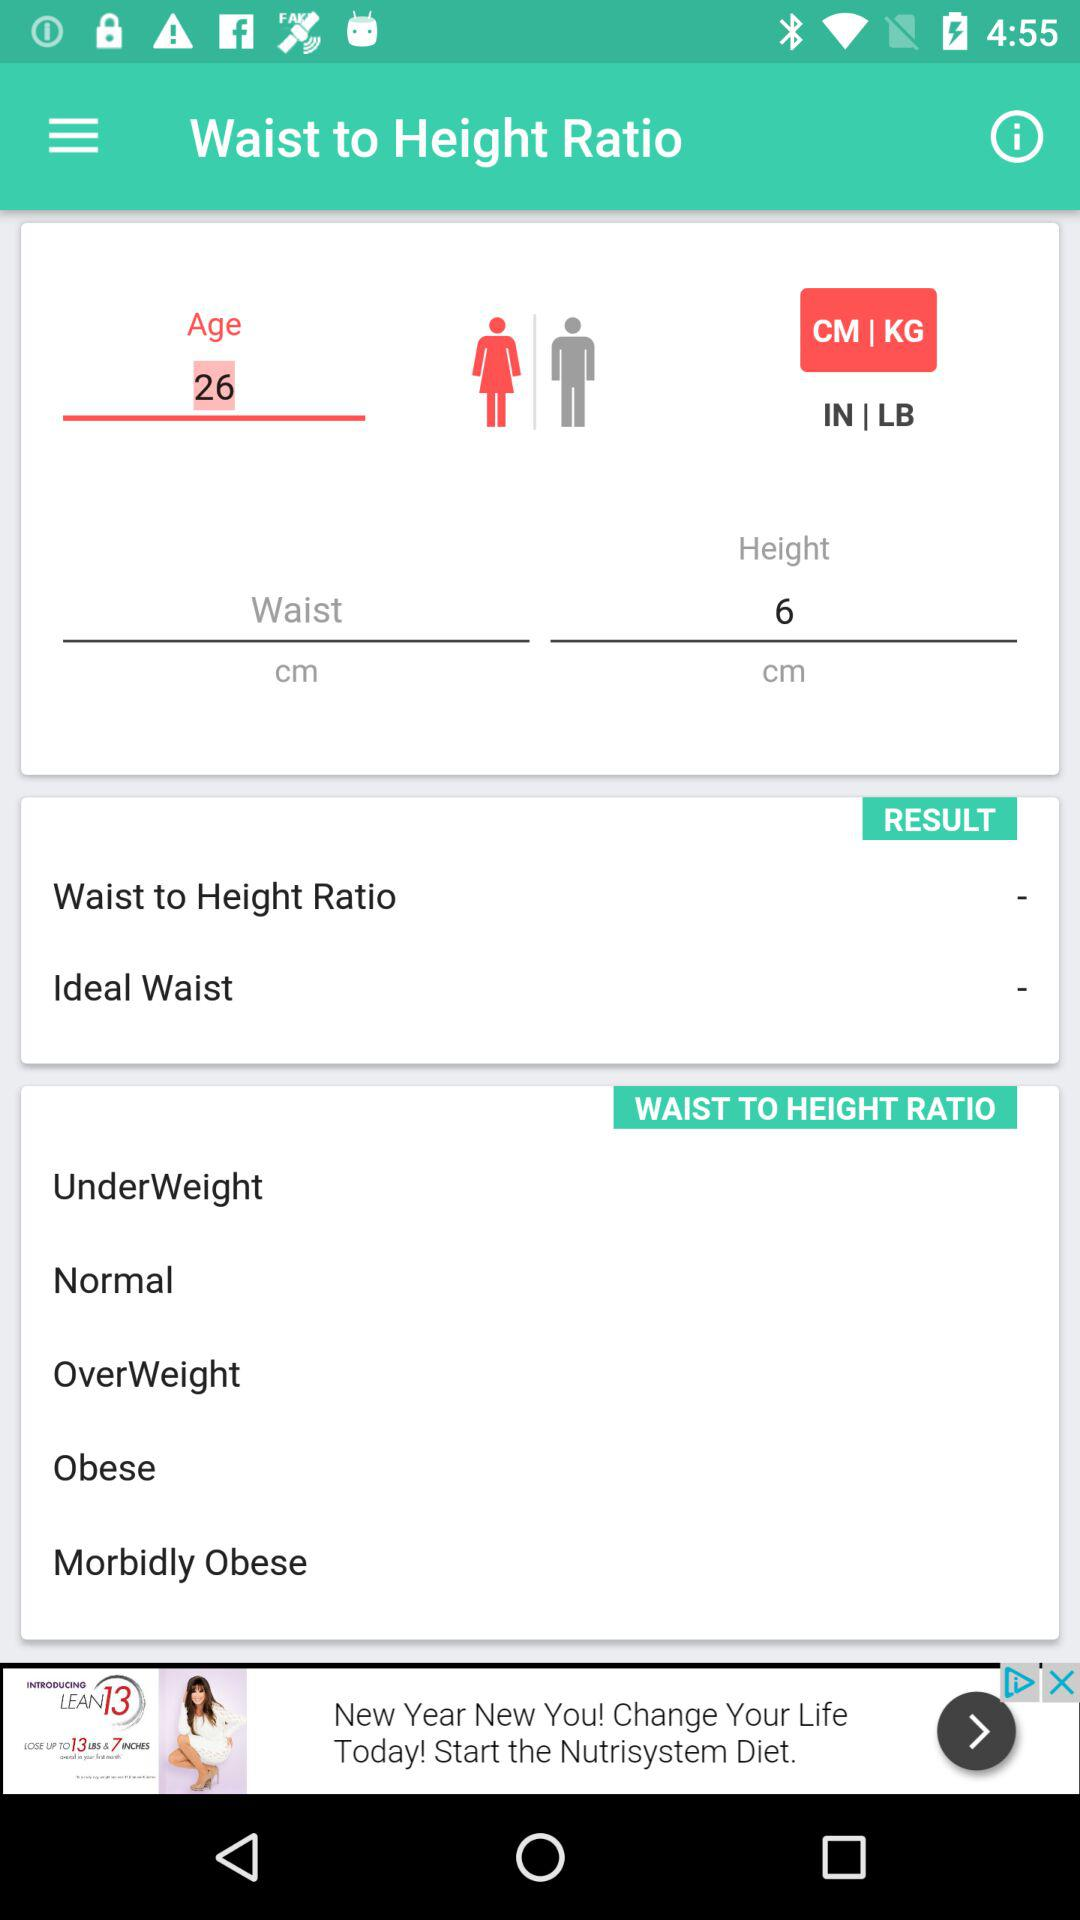How many centimeters is the waist size?
When the provided information is insufficient, respond with <no answer>. <no answer> 